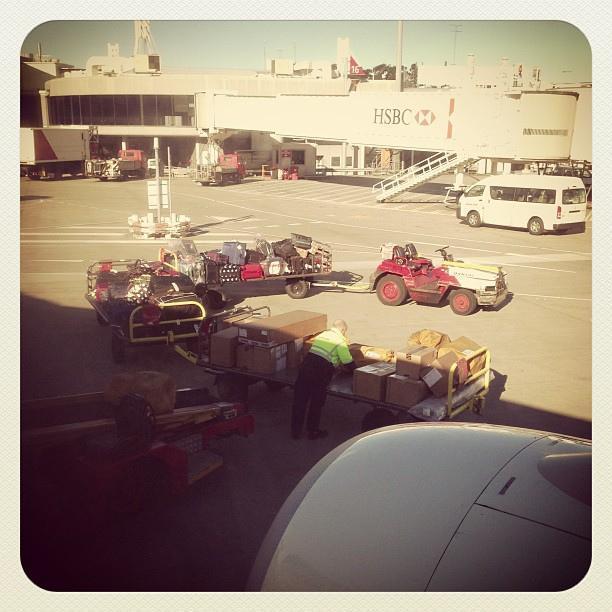How many trucks are there?
Give a very brief answer. 3. How many toilets are in this picture?
Give a very brief answer. 0. 